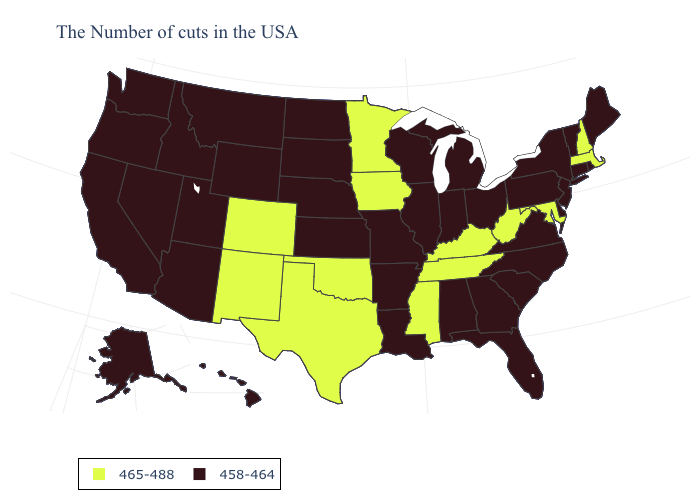Among the states that border Pennsylvania , which have the highest value?
Quick response, please. Maryland, West Virginia. How many symbols are there in the legend?
Quick response, please. 2. Among the states that border Mississippi , does Alabama have the highest value?
Write a very short answer. No. Does Florida have the same value as Colorado?
Write a very short answer. No. What is the value of Arizona?
Write a very short answer. 458-464. What is the value of Colorado?
Answer briefly. 465-488. Does Illinois have the same value as Louisiana?
Short answer required. Yes. How many symbols are there in the legend?
Write a very short answer. 2. Name the states that have a value in the range 458-464?
Write a very short answer. Maine, Rhode Island, Vermont, Connecticut, New York, New Jersey, Delaware, Pennsylvania, Virginia, North Carolina, South Carolina, Ohio, Florida, Georgia, Michigan, Indiana, Alabama, Wisconsin, Illinois, Louisiana, Missouri, Arkansas, Kansas, Nebraska, South Dakota, North Dakota, Wyoming, Utah, Montana, Arizona, Idaho, Nevada, California, Washington, Oregon, Alaska, Hawaii. What is the lowest value in the South?
Concise answer only. 458-464. Name the states that have a value in the range 465-488?
Short answer required. Massachusetts, New Hampshire, Maryland, West Virginia, Kentucky, Tennessee, Mississippi, Minnesota, Iowa, Oklahoma, Texas, Colorado, New Mexico. Among the states that border Ohio , does West Virginia have the highest value?
Write a very short answer. Yes. Name the states that have a value in the range 458-464?
Quick response, please. Maine, Rhode Island, Vermont, Connecticut, New York, New Jersey, Delaware, Pennsylvania, Virginia, North Carolina, South Carolina, Ohio, Florida, Georgia, Michigan, Indiana, Alabama, Wisconsin, Illinois, Louisiana, Missouri, Arkansas, Kansas, Nebraska, South Dakota, North Dakota, Wyoming, Utah, Montana, Arizona, Idaho, Nevada, California, Washington, Oregon, Alaska, Hawaii. Name the states that have a value in the range 465-488?
Be succinct. Massachusetts, New Hampshire, Maryland, West Virginia, Kentucky, Tennessee, Mississippi, Minnesota, Iowa, Oklahoma, Texas, Colorado, New Mexico. Which states hav the highest value in the Northeast?
Short answer required. Massachusetts, New Hampshire. 